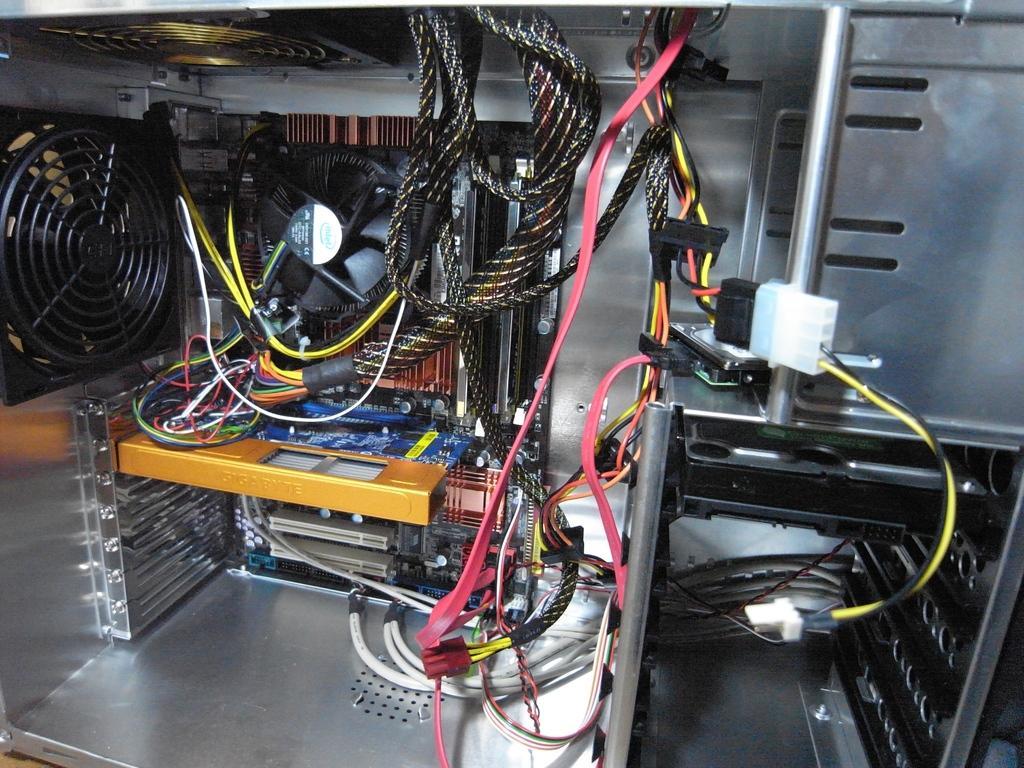How would you summarize this image in a sentence or two? This picture might be consists of interior view of CPU and in this we can see there are some fans, cable wires, board , some chip visible 